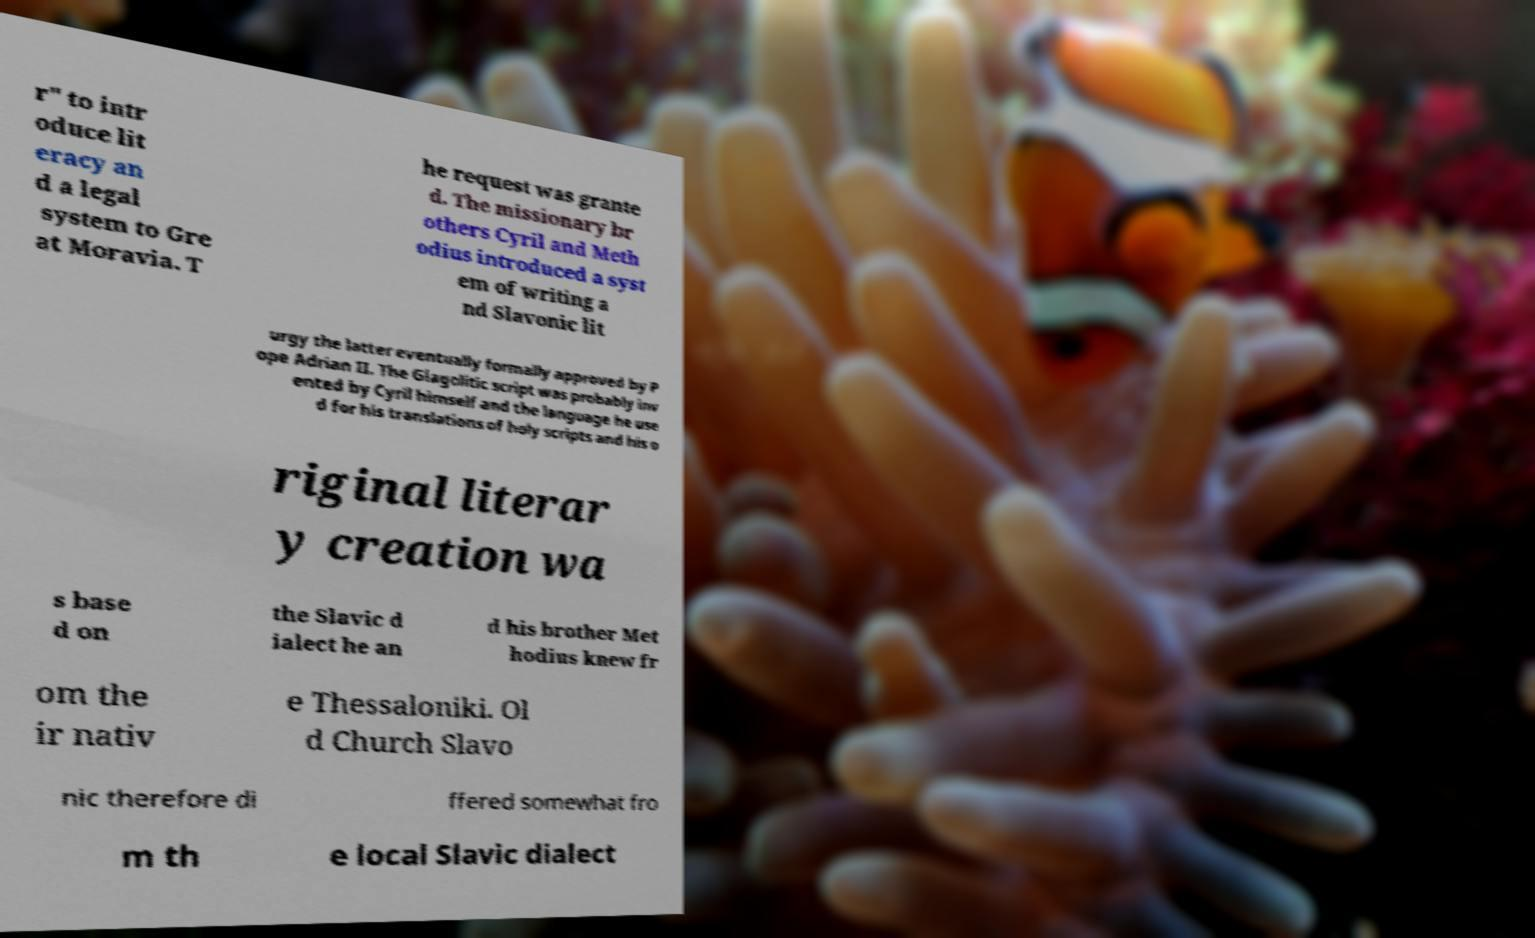Please identify and transcribe the text found in this image. r" to intr oduce lit eracy an d a legal system to Gre at Moravia. T he request was grante d. The missionary br others Cyril and Meth odius introduced a syst em of writing a nd Slavonic lit urgy the latter eventually formally approved by P ope Adrian II. The Glagolitic script was probably inv ented by Cyril himself and the language he use d for his translations of holy scripts and his o riginal literar y creation wa s base d on the Slavic d ialect he an d his brother Met hodius knew fr om the ir nativ e Thessaloniki. Ol d Church Slavo nic therefore di ffered somewhat fro m th e local Slavic dialect 